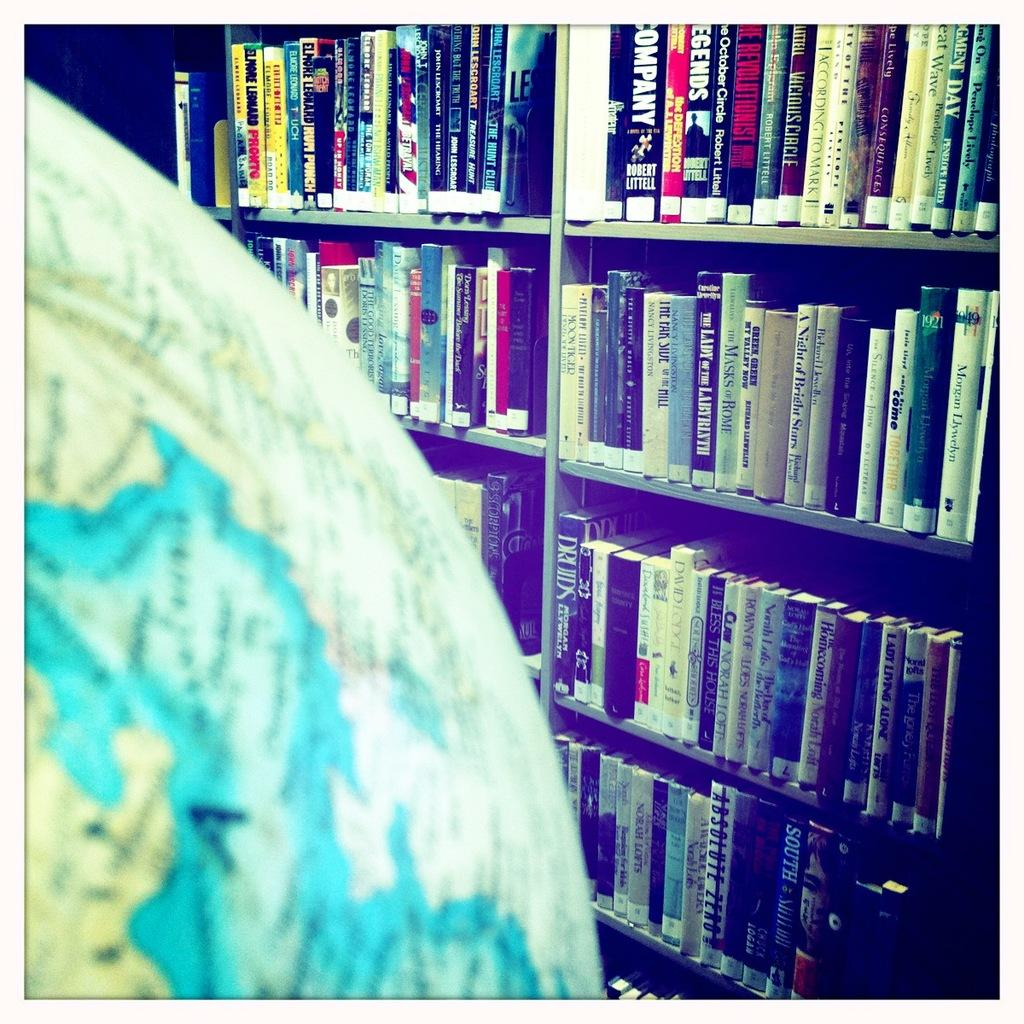<image>
Present a compact description of the photo's key features. Lots of books neatly stacked in the book shelf  and one of them is entitled The masks of Rome. 